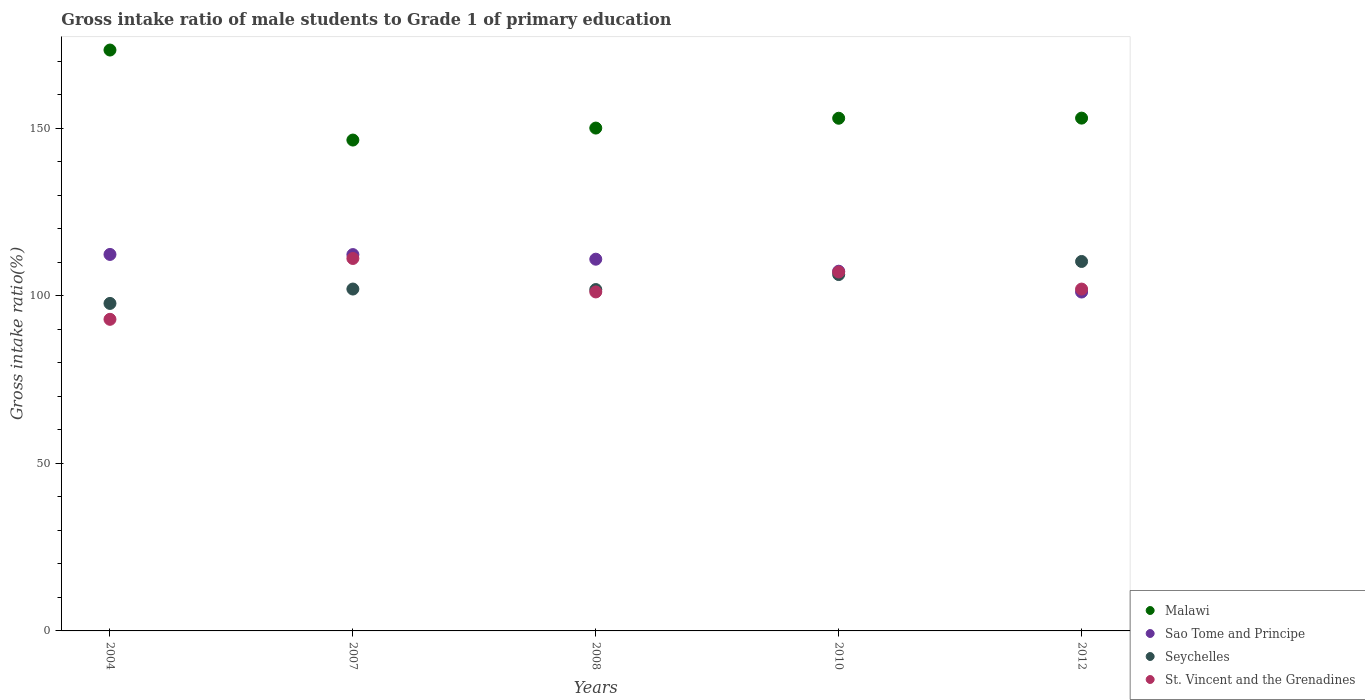How many different coloured dotlines are there?
Make the answer very short. 4. Is the number of dotlines equal to the number of legend labels?
Your answer should be compact. Yes. What is the gross intake ratio in St. Vincent and the Grenadines in 2012?
Provide a short and direct response. 101.97. Across all years, what is the maximum gross intake ratio in Malawi?
Provide a succinct answer. 173.28. Across all years, what is the minimum gross intake ratio in Sao Tome and Principe?
Provide a short and direct response. 101.09. What is the total gross intake ratio in St. Vincent and the Grenadines in the graph?
Provide a short and direct response. 514.21. What is the difference between the gross intake ratio in Sao Tome and Principe in 2004 and that in 2012?
Give a very brief answer. 11.21. What is the difference between the gross intake ratio in Malawi in 2008 and the gross intake ratio in Seychelles in 2007?
Your response must be concise. 48.02. What is the average gross intake ratio in Malawi per year?
Offer a very short reply. 155.12. In the year 2004, what is the difference between the gross intake ratio in Seychelles and gross intake ratio in Malawi?
Provide a short and direct response. -75.59. What is the ratio of the gross intake ratio in St. Vincent and the Grenadines in 2004 to that in 2012?
Offer a terse response. 0.91. What is the difference between the highest and the second highest gross intake ratio in Malawi?
Provide a short and direct response. 20.31. What is the difference between the highest and the lowest gross intake ratio in St. Vincent and the Grenadines?
Your answer should be very brief. 18.15. Is the gross intake ratio in Malawi strictly less than the gross intake ratio in St. Vincent and the Grenadines over the years?
Provide a succinct answer. No. How many dotlines are there?
Provide a short and direct response. 4. What is the difference between two consecutive major ticks on the Y-axis?
Give a very brief answer. 50. Where does the legend appear in the graph?
Keep it short and to the point. Bottom right. How many legend labels are there?
Provide a short and direct response. 4. How are the legend labels stacked?
Provide a succinct answer. Vertical. What is the title of the graph?
Your response must be concise. Gross intake ratio of male students to Grade 1 of primary education. Does "Cyprus" appear as one of the legend labels in the graph?
Provide a short and direct response. No. What is the label or title of the Y-axis?
Make the answer very short. Gross intake ratio(%). What is the Gross intake ratio(%) of Malawi in 2004?
Offer a terse response. 173.28. What is the Gross intake ratio(%) of Sao Tome and Principe in 2004?
Ensure brevity in your answer.  112.3. What is the Gross intake ratio(%) in Seychelles in 2004?
Provide a succinct answer. 97.69. What is the Gross intake ratio(%) in St. Vincent and the Grenadines in 2004?
Offer a very short reply. 92.95. What is the Gross intake ratio(%) in Malawi in 2007?
Make the answer very short. 146.43. What is the Gross intake ratio(%) in Sao Tome and Principe in 2007?
Provide a succinct answer. 112.26. What is the Gross intake ratio(%) of Seychelles in 2007?
Provide a succinct answer. 101.98. What is the Gross intake ratio(%) of St. Vincent and the Grenadines in 2007?
Make the answer very short. 111.1. What is the Gross intake ratio(%) of Malawi in 2008?
Make the answer very short. 150. What is the Gross intake ratio(%) of Sao Tome and Principe in 2008?
Make the answer very short. 110.88. What is the Gross intake ratio(%) of Seychelles in 2008?
Offer a very short reply. 101.83. What is the Gross intake ratio(%) of St. Vincent and the Grenadines in 2008?
Give a very brief answer. 101.12. What is the Gross intake ratio(%) in Malawi in 2010?
Provide a succinct answer. 152.93. What is the Gross intake ratio(%) in Sao Tome and Principe in 2010?
Provide a short and direct response. 107.3. What is the Gross intake ratio(%) in Seychelles in 2010?
Ensure brevity in your answer.  106.3. What is the Gross intake ratio(%) in St. Vincent and the Grenadines in 2010?
Your answer should be very brief. 107.07. What is the Gross intake ratio(%) of Malawi in 2012?
Offer a very short reply. 152.97. What is the Gross intake ratio(%) in Sao Tome and Principe in 2012?
Offer a very short reply. 101.09. What is the Gross intake ratio(%) in Seychelles in 2012?
Offer a very short reply. 110.21. What is the Gross intake ratio(%) of St. Vincent and the Grenadines in 2012?
Your answer should be very brief. 101.97. Across all years, what is the maximum Gross intake ratio(%) in Malawi?
Your response must be concise. 173.28. Across all years, what is the maximum Gross intake ratio(%) of Sao Tome and Principe?
Offer a very short reply. 112.3. Across all years, what is the maximum Gross intake ratio(%) in Seychelles?
Offer a terse response. 110.21. Across all years, what is the maximum Gross intake ratio(%) in St. Vincent and the Grenadines?
Your response must be concise. 111.1. Across all years, what is the minimum Gross intake ratio(%) in Malawi?
Your answer should be very brief. 146.43. Across all years, what is the minimum Gross intake ratio(%) of Sao Tome and Principe?
Provide a short and direct response. 101.09. Across all years, what is the minimum Gross intake ratio(%) in Seychelles?
Your answer should be very brief. 97.69. Across all years, what is the minimum Gross intake ratio(%) in St. Vincent and the Grenadines?
Keep it short and to the point. 92.95. What is the total Gross intake ratio(%) of Malawi in the graph?
Your answer should be compact. 775.6. What is the total Gross intake ratio(%) in Sao Tome and Principe in the graph?
Your answer should be compact. 543.84. What is the total Gross intake ratio(%) of Seychelles in the graph?
Ensure brevity in your answer.  518.02. What is the total Gross intake ratio(%) of St. Vincent and the Grenadines in the graph?
Your answer should be very brief. 514.21. What is the difference between the Gross intake ratio(%) in Malawi in 2004 and that in 2007?
Your answer should be very brief. 26.85. What is the difference between the Gross intake ratio(%) of Sao Tome and Principe in 2004 and that in 2007?
Your response must be concise. 0.04. What is the difference between the Gross intake ratio(%) of Seychelles in 2004 and that in 2007?
Provide a short and direct response. -4.29. What is the difference between the Gross intake ratio(%) in St. Vincent and the Grenadines in 2004 and that in 2007?
Your answer should be very brief. -18.15. What is the difference between the Gross intake ratio(%) of Malawi in 2004 and that in 2008?
Offer a terse response. 23.28. What is the difference between the Gross intake ratio(%) of Sao Tome and Principe in 2004 and that in 2008?
Provide a succinct answer. 1.42. What is the difference between the Gross intake ratio(%) of Seychelles in 2004 and that in 2008?
Keep it short and to the point. -4.14. What is the difference between the Gross intake ratio(%) in St. Vincent and the Grenadines in 2004 and that in 2008?
Provide a short and direct response. -8.17. What is the difference between the Gross intake ratio(%) of Malawi in 2004 and that in 2010?
Provide a succinct answer. 20.35. What is the difference between the Gross intake ratio(%) of Sao Tome and Principe in 2004 and that in 2010?
Give a very brief answer. 5. What is the difference between the Gross intake ratio(%) of Seychelles in 2004 and that in 2010?
Provide a short and direct response. -8.61. What is the difference between the Gross intake ratio(%) in St. Vincent and the Grenadines in 2004 and that in 2010?
Provide a short and direct response. -14.12. What is the difference between the Gross intake ratio(%) in Malawi in 2004 and that in 2012?
Provide a short and direct response. 20.31. What is the difference between the Gross intake ratio(%) of Sao Tome and Principe in 2004 and that in 2012?
Your response must be concise. 11.21. What is the difference between the Gross intake ratio(%) of Seychelles in 2004 and that in 2012?
Offer a terse response. -12.52. What is the difference between the Gross intake ratio(%) in St. Vincent and the Grenadines in 2004 and that in 2012?
Offer a very short reply. -9.02. What is the difference between the Gross intake ratio(%) in Malawi in 2007 and that in 2008?
Provide a succinct answer. -3.58. What is the difference between the Gross intake ratio(%) in Sao Tome and Principe in 2007 and that in 2008?
Your answer should be compact. 1.37. What is the difference between the Gross intake ratio(%) of Seychelles in 2007 and that in 2008?
Your answer should be very brief. 0.15. What is the difference between the Gross intake ratio(%) of St. Vincent and the Grenadines in 2007 and that in 2008?
Keep it short and to the point. 9.98. What is the difference between the Gross intake ratio(%) in Malawi in 2007 and that in 2010?
Offer a terse response. -6.5. What is the difference between the Gross intake ratio(%) of Sao Tome and Principe in 2007 and that in 2010?
Give a very brief answer. 4.96. What is the difference between the Gross intake ratio(%) of Seychelles in 2007 and that in 2010?
Ensure brevity in your answer.  -4.32. What is the difference between the Gross intake ratio(%) in St. Vincent and the Grenadines in 2007 and that in 2010?
Ensure brevity in your answer.  4.03. What is the difference between the Gross intake ratio(%) in Malawi in 2007 and that in 2012?
Your answer should be very brief. -6.54. What is the difference between the Gross intake ratio(%) in Sao Tome and Principe in 2007 and that in 2012?
Ensure brevity in your answer.  11.17. What is the difference between the Gross intake ratio(%) of Seychelles in 2007 and that in 2012?
Your answer should be very brief. -8.22. What is the difference between the Gross intake ratio(%) in St. Vincent and the Grenadines in 2007 and that in 2012?
Provide a succinct answer. 9.13. What is the difference between the Gross intake ratio(%) of Malawi in 2008 and that in 2010?
Ensure brevity in your answer.  -2.93. What is the difference between the Gross intake ratio(%) of Sao Tome and Principe in 2008 and that in 2010?
Give a very brief answer. 3.59. What is the difference between the Gross intake ratio(%) of Seychelles in 2008 and that in 2010?
Provide a succinct answer. -4.47. What is the difference between the Gross intake ratio(%) of St. Vincent and the Grenadines in 2008 and that in 2010?
Provide a short and direct response. -5.95. What is the difference between the Gross intake ratio(%) of Malawi in 2008 and that in 2012?
Offer a terse response. -2.97. What is the difference between the Gross intake ratio(%) of Sao Tome and Principe in 2008 and that in 2012?
Give a very brief answer. 9.79. What is the difference between the Gross intake ratio(%) of Seychelles in 2008 and that in 2012?
Offer a terse response. -8.38. What is the difference between the Gross intake ratio(%) in St. Vincent and the Grenadines in 2008 and that in 2012?
Offer a very short reply. -0.85. What is the difference between the Gross intake ratio(%) in Malawi in 2010 and that in 2012?
Make the answer very short. -0.04. What is the difference between the Gross intake ratio(%) in Sao Tome and Principe in 2010 and that in 2012?
Your response must be concise. 6.21. What is the difference between the Gross intake ratio(%) of Seychelles in 2010 and that in 2012?
Your response must be concise. -3.9. What is the difference between the Gross intake ratio(%) of St. Vincent and the Grenadines in 2010 and that in 2012?
Your response must be concise. 5.1. What is the difference between the Gross intake ratio(%) of Malawi in 2004 and the Gross intake ratio(%) of Sao Tome and Principe in 2007?
Keep it short and to the point. 61.02. What is the difference between the Gross intake ratio(%) in Malawi in 2004 and the Gross intake ratio(%) in Seychelles in 2007?
Offer a very short reply. 71.29. What is the difference between the Gross intake ratio(%) of Malawi in 2004 and the Gross intake ratio(%) of St. Vincent and the Grenadines in 2007?
Offer a terse response. 62.18. What is the difference between the Gross intake ratio(%) of Sao Tome and Principe in 2004 and the Gross intake ratio(%) of Seychelles in 2007?
Offer a terse response. 10.32. What is the difference between the Gross intake ratio(%) of Sao Tome and Principe in 2004 and the Gross intake ratio(%) of St. Vincent and the Grenadines in 2007?
Offer a terse response. 1.2. What is the difference between the Gross intake ratio(%) of Seychelles in 2004 and the Gross intake ratio(%) of St. Vincent and the Grenadines in 2007?
Offer a very short reply. -13.41. What is the difference between the Gross intake ratio(%) in Malawi in 2004 and the Gross intake ratio(%) in Sao Tome and Principe in 2008?
Give a very brief answer. 62.39. What is the difference between the Gross intake ratio(%) of Malawi in 2004 and the Gross intake ratio(%) of Seychelles in 2008?
Make the answer very short. 71.45. What is the difference between the Gross intake ratio(%) in Malawi in 2004 and the Gross intake ratio(%) in St. Vincent and the Grenadines in 2008?
Make the answer very short. 72.16. What is the difference between the Gross intake ratio(%) in Sao Tome and Principe in 2004 and the Gross intake ratio(%) in Seychelles in 2008?
Provide a short and direct response. 10.47. What is the difference between the Gross intake ratio(%) of Sao Tome and Principe in 2004 and the Gross intake ratio(%) of St. Vincent and the Grenadines in 2008?
Make the answer very short. 11.18. What is the difference between the Gross intake ratio(%) of Seychelles in 2004 and the Gross intake ratio(%) of St. Vincent and the Grenadines in 2008?
Make the answer very short. -3.43. What is the difference between the Gross intake ratio(%) of Malawi in 2004 and the Gross intake ratio(%) of Sao Tome and Principe in 2010?
Give a very brief answer. 65.98. What is the difference between the Gross intake ratio(%) of Malawi in 2004 and the Gross intake ratio(%) of Seychelles in 2010?
Your answer should be compact. 66.97. What is the difference between the Gross intake ratio(%) in Malawi in 2004 and the Gross intake ratio(%) in St. Vincent and the Grenadines in 2010?
Your answer should be very brief. 66.2. What is the difference between the Gross intake ratio(%) of Sao Tome and Principe in 2004 and the Gross intake ratio(%) of Seychelles in 2010?
Provide a short and direct response. 6. What is the difference between the Gross intake ratio(%) in Sao Tome and Principe in 2004 and the Gross intake ratio(%) in St. Vincent and the Grenadines in 2010?
Ensure brevity in your answer.  5.23. What is the difference between the Gross intake ratio(%) in Seychelles in 2004 and the Gross intake ratio(%) in St. Vincent and the Grenadines in 2010?
Provide a succinct answer. -9.38. What is the difference between the Gross intake ratio(%) of Malawi in 2004 and the Gross intake ratio(%) of Sao Tome and Principe in 2012?
Your answer should be compact. 72.19. What is the difference between the Gross intake ratio(%) of Malawi in 2004 and the Gross intake ratio(%) of Seychelles in 2012?
Your answer should be compact. 63.07. What is the difference between the Gross intake ratio(%) in Malawi in 2004 and the Gross intake ratio(%) in St. Vincent and the Grenadines in 2012?
Offer a terse response. 71.3. What is the difference between the Gross intake ratio(%) in Sao Tome and Principe in 2004 and the Gross intake ratio(%) in Seychelles in 2012?
Make the answer very short. 2.1. What is the difference between the Gross intake ratio(%) in Sao Tome and Principe in 2004 and the Gross intake ratio(%) in St. Vincent and the Grenadines in 2012?
Give a very brief answer. 10.33. What is the difference between the Gross intake ratio(%) in Seychelles in 2004 and the Gross intake ratio(%) in St. Vincent and the Grenadines in 2012?
Give a very brief answer. -4.28. What is the difference between the Gross intake ratio(%) in Malawi in 2007 and the Gross intake ratio(%) in Sao Tome and Principe in 2008?
Make the answer very short. 35.54. What is the difference between the Gross intake ratio(%) of Malawi in 2007 and the Gross intake ratio(%) of Seychelles in 2008?
Provide a short and direct response. 44.59. What is the difference between the Gross intake ratio(%) of Malawi in 2007 and the Gross intake ratio(%) of St. Vincent and the Grenadines in 2008?
Your answer should be compact. 45.31. What is the difference between the Gross intake ratio(%) of Sao Tome and Principe in 2007 and the Gross intake ratio(%) of Seychelles in 2008?
Provide a succinct answer. 10.43. What is the difference between the Gross intake ratio(%) of Sao Tome and Principe in 2007 and the Gross intake ratio(%) of St. Vincent and the Grenadines in 2008?
Your response must be concise. 11.14. What is the difference between the Gross intake ratio(%) of Seychelles in 2007 and the Gross intake ratio(%) of St. Vincent and the Grenadines in 2008?
Offer a terse response. 0.86. What is the difference between the Gross intake ratio(%) of Malawi in 2007 and the Gross intake ratio(%) of Sao Tome and Principe in 2010?
Make the answer very short. 39.13. What is the difference between the Gross intake ratio(%) in Malawi in 2007 and the Gross intake ratio(%) in Seychelles in 2010?
Provide a short and direct response. 40.12. What is the difference between the Gross intake ratio(%) in Malawi in 2007 and the Gross intake ratio(%) in St. Vincent and the Grenadines in 2010?
Ensure brevity in your answer.  39.35. What is the difference between the Gross intake ratio(%) of Sao Tome and Principe in 2007 and the Gross intake ratio(%) of Seychelles in 2010?
Offer a very short reply. 5.95. What is the difference between the Gross intake ratio(%) in Sao Tome and Principe in 2007 and the Gross intake ratio(%) in St. Vincent and the Grenadines in 2010?
Make the answer very short. 5.18. What is the difference between the Gross intake ratio(%) of Seychelles in 2007 and the Gross intake ratio(%) of St. Vincent and the Grenadines in 2010?
Your answer should be compact. -5.09. What is the difference between the Gross intake ratio(%) of Malawi in 2007 and the Gross intake ratio(%) of Sao Tome and Principe in 2012?
Provide a succinct answer. 45.33. What is the difference between the Gross intake ratio(%) in Malawi in 2007 and the Gross intake ratio(%) in Seychelles in 2012?
Give a very brief answer. 36.22. What is the difference between the Gross intake ratio(%) in Malawi in 2007 and the Gross intake ratio(%) in St. Vincent and the Grenadines in 2012?
Your answer should be compact. 44.45. What is the difference between the Gross intake ratio(%) in Sao Tome and Principe in 2007 and the Gross intake ratio(%) in Seychelles in 2012?
Provide a succinct answer. 2.05. What is the difference between the Gross intake ratio(%) of Sao Tome and Principe in 2007 and the Gross intake ratio(%) of St. Vincent and the Grenadines in 2012?
Provide a short and direct response. 10.29. What is the difference between the Gross intake ratio(%) of Seychelles in 2007 and the Gross intake ratio(%) of St. Vincent and the Grenadines in 2012?
Your answer should be very brief. 0.01. What is the difference between the Gross intake ratio(%) of Malawi in 2008 and the Gross intake ratio(%) of Sao Tome and Principe in 2010?
Your answer should be very brief. 42.7. What is the difference between the Gross intake ratio(%) in Malawi in 2008 and the Gross intake ratio(%) in Seychelles in 2010?
Your answer should be compact. 43.7. What is the difference between the Gross intake ratio(%) of Malawi in 2008 and the Gross intake ratio(%) of St. Vincent and the Grenadines in 2010?
Provide a short and direct response. 42.93. What is the difference between the Gross intake ratio(%) of Sao Tome and Principe in 2008 and the Gross intake ratio(%) of Seychelles in 2010?
Your answer should be very brief. 4.58. What is the difference between the Gross intake ratio(%) in Sao Tome and Principe in 2008 and the Gross intake ratio(%) in St. Vincent and the Grenadines in 2010?
Keep it short and to the point. 3.81. What is the difference between the Gross intake ratio(%) of Seychelles in 2008 and the Gross intake ratio(%) of St. Vincent and the Grenadines in 2010?
Offer a terse response. -5.24. What is the difference between the Gross intake ratio(%) in Malawi in 2008 and the Gross intake ratio(%) in Sao Tome and Principe in 2012?
Keep it short and to the point. 48.91. What is the difference between the Gross intake ratio(%) in Malawi in 2008 and the Gross intake ratio(%) in Seychelles in 2012?
Your answer should be very brief. 39.79. What is the difference between the Gross intake ratio(%) of Malawi in 2008 and the Gross intake ratio(%) of St. Vincent and the Grenadines in 2012?
Your response must be concise. 48.03. What is the difference between the Gross intake ratio(%) of Sao Tome and Principe in 2008 and the Gross intake ratio(%) of Seychelles in 2012?
Ensure brevity in your answer.  0.68. What is the difference between the Gross intake ratio(%) of Sao Tome and Principe in 2008 and the Gross intake ratio(%) of St. Vincent and the Grenadines in 2012?
Your answer should be compact. 8.91. What is the difference between the Gross intake ratio(%) in Seychelles in 2008 and the Gross intake ratio(%) in St. Vincent and the Grenadines in 2012?
Give a very brief answer. -0.14. What is the difference between the Gross intake ratio(%) in Malawi in 2010 and the Gross intake ratio(%) in Sao Tome and Principe in 2012?
Keep it short and to the point. 51.84. What is the difference between the Gross intake ratio(%) in Malawi in 2010 and the Gross intake ratio(%) in Seychelles in 2012?
Provide a short and direct response. 42.72. What is the difference between the Gross intake ratio(%) of Malawi in 2010 and the Gross intake ratio(%) of St. Vincent and the Grenadines in 2012?
Keep it short and to the point. 50.96. What is the difference between the Gross intake ratio(%) of Sao Tome and Principe in 2010 and the Gross intake ratio(%) of Seychelles in 2012?
Keep it short and to the point. -2.91. What is the difference between the Gross intake ratio(%) of Sao Tome and Principe in 2010 and the Gross intake ratio(%) of St. Vincent and the Grenadines in 2012?
Give a very brief answer. 5.33. What is the difference between the Gross intake ratio(%) in Seychelles in 2010 and the Gross intake ratio(%) in St. Vincent and the Grenadines in 2012?
Provide a succinct answer. 4.33. What is the average Gross intake ratio(%) in Malawi per year?
Ensure brevity in your answer.  155.12. What is the average Gross intake ratio(%) in Sao Tome and Principe per year?
Your answer should be very brief. 108.77. What is the average Gross intake ratio(%) of Seychelles per year?
Make the answer very short. 103.6. What is the average Gross intake ratio(%) in St. Vincent and the Grenadines per year?
Make the answer very short. 102.84. In the year 2004, what is the difference between the Gross intake ratio(%) of Malawi and Gross intake ratio(%) of Sao Tome and Principe?
Keep it short and to the point. 60.97. In the year 2004, what is the difference between the Gross intake ratio(%) of Malawi and Gross intake ratio(%) of Seychelles?
Make the answer very short. 75.59. In the year 2004, what is the difference between the Gross intake ratio(%) of Malawi and Gross intake ratio(%) of St. Vincent and the Grenadines?
Ensure brevity in your answer.  80.33. In the year 2004, what is the difference between the Gross intake ratio(%) in Sao Tome and Principe and Gross intake ratio(%) in Seychelles?
Offer a very short reply. 14.61. In the year 2004, what is the difference between the Gross intake ratio(%) in Sao Tome and Principe and Gross intake ratio(%) in St. Vincent and the Grenadines?
Your response must be concise. 19.35. In the year 2004, what is the difference between the Gross intake ratio(%) of Seychelles and Gross intake ratio(%) of St. Vincent and the Grenadines?
Your response must be concise. 4.74. In the year 2007, what is the difference between the Gross intake ratio(%) in Malawi and Gross intake ratio(%) in Sao Tome and Principe?
Give a very brief answer. 34.17. In the year 2007, what is the difference between the Gross intake ratio(%) of Malawi and Gross intake ratio(%) of Seychelles?
Give a very brief answer. 44.44. In the year 2007, what is the difference between the Gross intake ratio(%) in Malawi and Gross intake ratio(%) in St. Vincent and the Grenadines?
Provide a short and direct response. 35.33. In the year 2007, what is the difference between the Gross intake ratio(%) in Sao Tome and Principe and Gross intake ratio(%) in Seychelles?
Offer a terse response. 10.28. In the year 2007, what is the difference between the Gross intake ratio(%) of Sao Tome and Principe and Gross intake ratio(%) of St. Vincent and the Grenadines?
Provide a short and direct response. 1.16. In the year 2007, what is the difference between the Gross intake ratio(%) of Seychelles and Gross intake ratio(%) of St. Vincent and the Grenadines?
Give a very brief answer. -9.12. In the year 2008, what is the difference between the Gross intake ratio(%) of Malawi and Gross intake ratio(%) of Sao Tome and Principe?
Your answer should be compact. 39.12. In the year 2008, what is the difference between the Gross intake ratio(%) in Malawi and Gross intake ratio(%) in Seychelles?
Ensure brevity in your answer.  48.17. In the year 2008, what is the difference between the Gross intake ratio(%) of Malawi and Gross intake ratio(%) of St. Vincent and the Grenadines?
Your response must be concise. 48.88. In the year 2008, what is the difference between the Gross intake ratio(%) of Sao Tome and Principe and Gross intake ratio(%) of Seychelles?
Make the answer very short. 9.05. In the year 2008, what is the difference between the Gross intake ratio(%) in Sao Tome and Principe and Gross intake ratio(%) in St. Vincent and the Grenadines?
Offer a very short reply. 9.77. In the year 2008, what is the difference between the Gross intake ratio(%) in Seychelles and Gross intake ratio(%) in St. Vincent and the Grenadines?
Offer a terse response. 0.71. In the year 2010, what is the difference between the Gross intake ratio(%) in Malawi and Gross intake ratio(%) in Sao Tome and Principe?
Your response must be concise. 45.63. In the year 2010, what is the difference between the Gross intake ratio(%) of Malawi and Gross intake ratio(%) of Seychelles?
Provide a succinct answer. 46.62. In the year 2010, what is the difference between the Gross intake ratio(%) in Malawi and Gross intake ratio(%) in St. Vincent and the Grenadines?
Make the answer very short. 45.86. In the year 2010, what is the difference between the Gross intake ratio(%) of Sao Tome and Principe and Gross intake ratio(%) of Seychelles?
Offer a terse response. 0.99. In the year 2010, what is the difference between the Gross intake ratio(%) of Sao Tome and Principe and Gross intake ratio(%) of St. Vincent and the Grenadines?
Provide a short and direct response. 0.23. In the year 2010, what is the difference between the Gross intake ratio(%) in Seychelles and Gross intake ratio(%) in St. Vincent and the Grenadines?
Provide a succinct answer. -0.77. In the year 2012, what is the difference between the Gross intake ratio(%) of Malawi and Gross intake ratio(%) of Sao Tome and Principe?
Your response must be concise. 51.88. In the year 2012, what is the difference between the Gross intake ratio(%) of Malawi and Gross intake ratio(%) of Seychelles?
Ensure brevity in your answer.  42.76. In the year 2012, what is the difference between the Gross intake ratio(%) of Malawi and Gross intake ratio(%) of St. Vincent and the Grenadines?
Ensure brevity in your answer.  51. In the year 2012, what is the difference between the Gross intake ratio(%) in Sao Tome and Principe and Gross intake ratio(%) in Seychelles?
Provide a short and direct response. -9.12. In the year 2012, what is the difference between the Gross intake ratio(%) of Sao Tome and Principe and Gross intake ratio(%) of St. Vincent and the Grenadines?
Ensure brevity in your answer.  -0.88. In the year 2012, what is the difference between the Gross intake ratio(%) in Seychelles and Gross intake ratio(%) in St. Vincent and the Grenadines?
Give a very brief answer. 8.24. What is the ratio of the Gross intake ratio(%) in Malawi in 2004 to that in 2007?
Provide a short and direct response. 1.18. What is the ratio of the Gross intake ratio(%) in Sao Tome and Principe in 2004 to that in 2007?
Your response must be concise. 1. What is the ratio of the Gross intake ratio(%) in Seychelles in 2004 to that in 2007?
Ensure brevity in your answer.  0.96. What is the ratio of the Gross intake ratio(%) of St. Vincent and the Grenadines in 2004 to that in 2007?
Make the answer very short. 0.84. What is the ratio of the Gross intake ratio(%) in Malawi in 2004 to that in 2008?
Your answer should be very brief. 1.16. What is the ratio of the Gross intake ratio(%) in Sao Tome and Principe in 2004 to that in 2008?
Offer a very short reply. 1.01. What is the ratio of the Gross intake ratio(%) of Seychelles in 2004 to that in 2008?
Ensure brevity in your answer.  0.96. What is the ratio of the Gross intake ratio(%) in St. Vincent and the Grenadines in 2004 to that in 2008?
Give a very brief answer. 0.92. What is the ratio of the Gross intake ratio(%) in Malawi in 2004 to that in 2010?
Your answer should be compact. 1.13. What is the ratio of the Gross intake ratio(%) in Sao Tome and Principe in 2004 to that in 2010?
Your answer should be very brief. 1.05. What is the ratio of the Gross intake ratio(%) of Seychelles in 2004 to that in 2010?
Ensure brevity in your answer.  0.92. What is the ratio of the Gross intake ratio(%) in St. Vincent and the Grenadines in 2004 to that in 2010?
Give a very brief answer. 0.87. What is the ratio of the Gross intake ratio(%) of Malawi in 2004 to that in 2012?
Give a very brief answer. 1.13. What is the ratio of the Gross intake ratio(%) in Sao Tome and Principe in 2004 to that in 2012?
Give a very brief answer. 1.11. What is the ratio of the Gross intake ratio(%) in Seychelles in 2004 to that in 2012?
Offer a terse response. 0.89. What is the ratio of the Gross intake ratio(%) of St. Vincent and the Grenadines in 2004 to that in 2012?
Offer a very short reply. 0.91. What is the ratio of the Gross intake ratio(%) in Malawi in 2007 to that in 2008?
Provide a short and direct response. 0.98. What is the ratio of the Gross intake ratio(%) in Sao Tome and Principe in 2007 to that in 2008?
Make the answer very short. 1.01. What is the ratio of the Gross intake ratio(%) of St. Vincent and the Grenadines in 2007 to that in 2008?
Ensure brevity in your answer.  1.1. What is the ratio of the Gross intake ratio(%) of Malawi in 2007 to that in 2010?
Make the answer very short. 0.96. What is the ratio of the Gross intake ratio(%) of Sao Tome and Principe in 2007 to that in 2010?
Ensure brevity in your answer.  1.05. What is the ratio of the Gross intake ratio(%) of Seychelles in 2007 to that in 2010?
Provide a short and direct response. 0.96. What is the ratio of the Gross intake ratio(%) in St. Vincent and the Grenadines in 2007 to that in 2010?
Give a very brief answer. 1.04. What is the ratio of the Gross intake ratio(%) of Malawi in 2007 to that in 2012?
Give a very brief answer. 0.96. What is the ratio of the Gross intake ratio(%) of Sao Tome and Principe in 2007 to that in 2012?
Offer a very short reply. 1.11. What is the ratio of the Gross intake ratio(%) in Seychelles in 2007 to that in 2012?
Offer a terse response. 0.93. What is the ratio of the Gross intake ratio(%) in St. Vincent and the Grenadines in 2007 to that in 2012?
Offer a terse response. 1.09. What is the ratio of the Gross intake ratio(%) in Malawi in 2008 to that in 2010?
Provide a succinct answer. 0.98. What is the ratio of the Gross intake ratio(%) of Sao Tome and Principe in 2008 to that in 2010?
Offer a terse response. 1.03. What is the ratio of the Gross intake ratio(%) of Seychelles in 2008 to that in 2010?
Make the answer very short. 0.96. What is the ratio of the Gross intake ratio(%) in St. Vincent and the Grenadines in 2008 to that in 2010?
Your answer should be very brief. 0.94. What is the ratio of the Gross intake ratio(%) of Malawi in 2008 to that in 2012?
Make the answer very short. 0.98. What is the ratio of the Gross intake ratio(%) in Sao Tome and Principe in 2008 to that in 2012?
Offer a very short reply. 1.1. What is the ratio of the Gross intake ratio(%) of Seychelles in 2008 to that in 2012?
Offer a terse response. 0.92. What is the ratio of the Gross intake ratio(%) of Sao Tome and Principe in 2010 to that in 2012?
Ensure brevity in your answer.  1.06. What is the ratio of the Gross intake ratio(%) in Seychelles in 2010 to that in 2012?
Offer a very short reply. 0.96. What is the difference between the highest and the second highest Gross intake ratio(%) in Malawi?
Keep it short and to the point. 20.31. What is the difference between the highest and the second highest Gross intake ratio(%) of Sao Tome and Principe?
Your response must be concise. 0.04. What is the difference between the highest and the second highest Gross intake ratio(%) of Seychelles?
Provide a short and direct response. 3.9. What is the difference between the highest and the second highest Gross intake ratio(%) in St. Vincent and the Grenadines?
Ensure brevity in your answer.  4.03. What is the difference between the highest and the lowest Gross intake ratio(%) of Malawi?
Make the answer very short. 26.85. What is the difference between the highest and the lowest Gross intake ratio(%) in Sao Tome and Principe?
Keep it short and to the point. 11.21. What is the difference between the highest and the lowest Gross intake ratio(%) of Seychelles?
Ensure brevity in your answer.  12.52. What is the difference between the highest and the lowest Gross intake ratio(%) of St. Vincent and the Grenadines?
Offer a terse response. 18.15. 